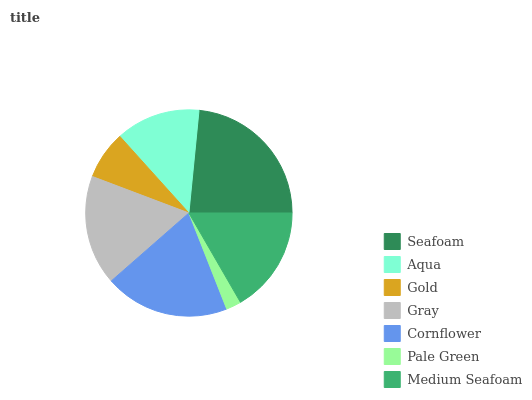Is Pale Green the minimum?
Answer yes or no. Yes. Is Seafoam the maximum?
Answer yes or no. Yes. Is Aqua the minimum?
Answer yes or no. No. Is Aqua the maximum?
Answer yes or no. No. Is Seafoam greater than Aqua?
Answer yes or no. Yes. Is Aqua less than Seafoam?
Answer yes or no. Yes. Is Aqua greater than Seafoam?
Answer yes or no. No. Is Seafoam less than Aqua?
Answer yes or no. No. Is Medium Seafoam the high median?
Answer yes or no. Yes. Is Medium Seafoam the low median?
Answer yes or no. Yes. Is Pale Green the high median?
Answer yes or no. No. Is Aqua the low median?
Answer yes or no. No. 